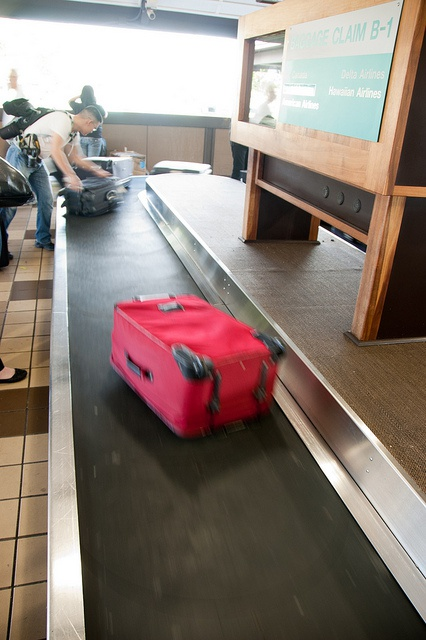Describe the objects in this image and their specific colors. I can see suitcase in gray, salmon, brown, and maroon tones, people in gray, lightgray, darkgray, black, and tan tones, suitcase in gray, black, darkgray, and purple tones, people in gray, darkgray, and lightgray tones, and people in gray, black, purple, and darkblue tones in this image. 